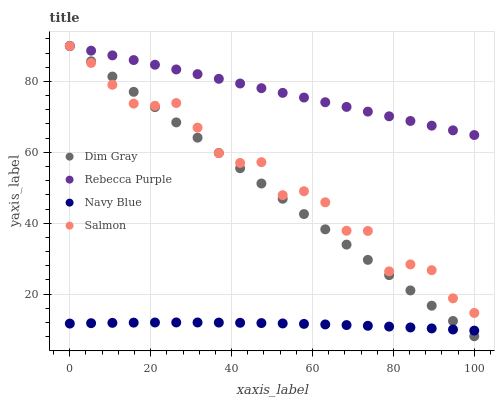Does Navy Blue have the minimum area under the curve?
Answer yes or no. Yes. Does Rebecca Purple have the maximum area under the curve?
Answer yes or no. Yes. Does Dim Gray have the minimum area under the curve?
Answer yes or no. No. Does Dim Gray have the maximum area under the curve?
Answer yes or no. No. Is Dim Gray the smoothest?
Answer yes or no. Yes. Is Salmon the roughest?
Answer yes or no. Yes. Is Salmon the smoothest?
Answer yes or no. No. Is Dim Gray the roughest?
Answer yes or no. No. Does Dim Gray have the lowest value?
Answer yes or no. Yes. Does Salmon have the lowest value?
Answer yes or no. No. Does Rebecca Purple have the highest value?
Answer yes or no. Yes. Is Navy Blue less than Rebecca Purple?
Answer yes or no. Yes. Is Rebecca Purple greater than Navy Blue?
Answer yes or no. Yes. Does Dim Gray intersect Salmon?
Answer yes or no. Yes. Is Dim Gray less than Salmon?
Answer yes or no. No. Is Dim Gray greater than Salmon?
Answer yes or no. No. Does Navy Blue intersect Rebecca Purple?
Answer yes or no. No. 